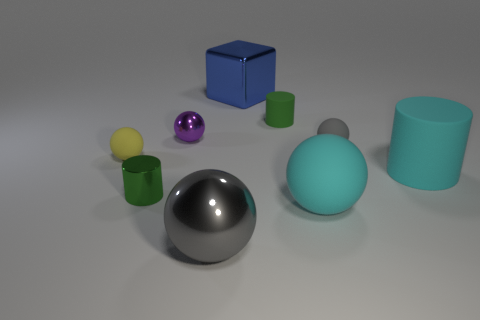Subtract all brown cubes. How many green cylinders are left? 2 Subtract all gray balls. How many balls are left? 3 Subtract all small cylinders. How many cylinders are left? 1 Subtract all cyan spheres. Subtract all purple cylinders. How many spheres are left? 4 Add 1 purple metallic things. How many objects exist? 10 Subtract all cylinders. How many objects are left? 6 Subtract 0 gray cylinders. How many objects are left? 9 Subtract all big cyan rubber cylinders. Subtract all large cyan cylinders. How many objects are left? 7 Add 2 cyan balls. How many cyan balls are left? 3 Add 3 gray matte cubes. How many gray matte cubes exist? 3 